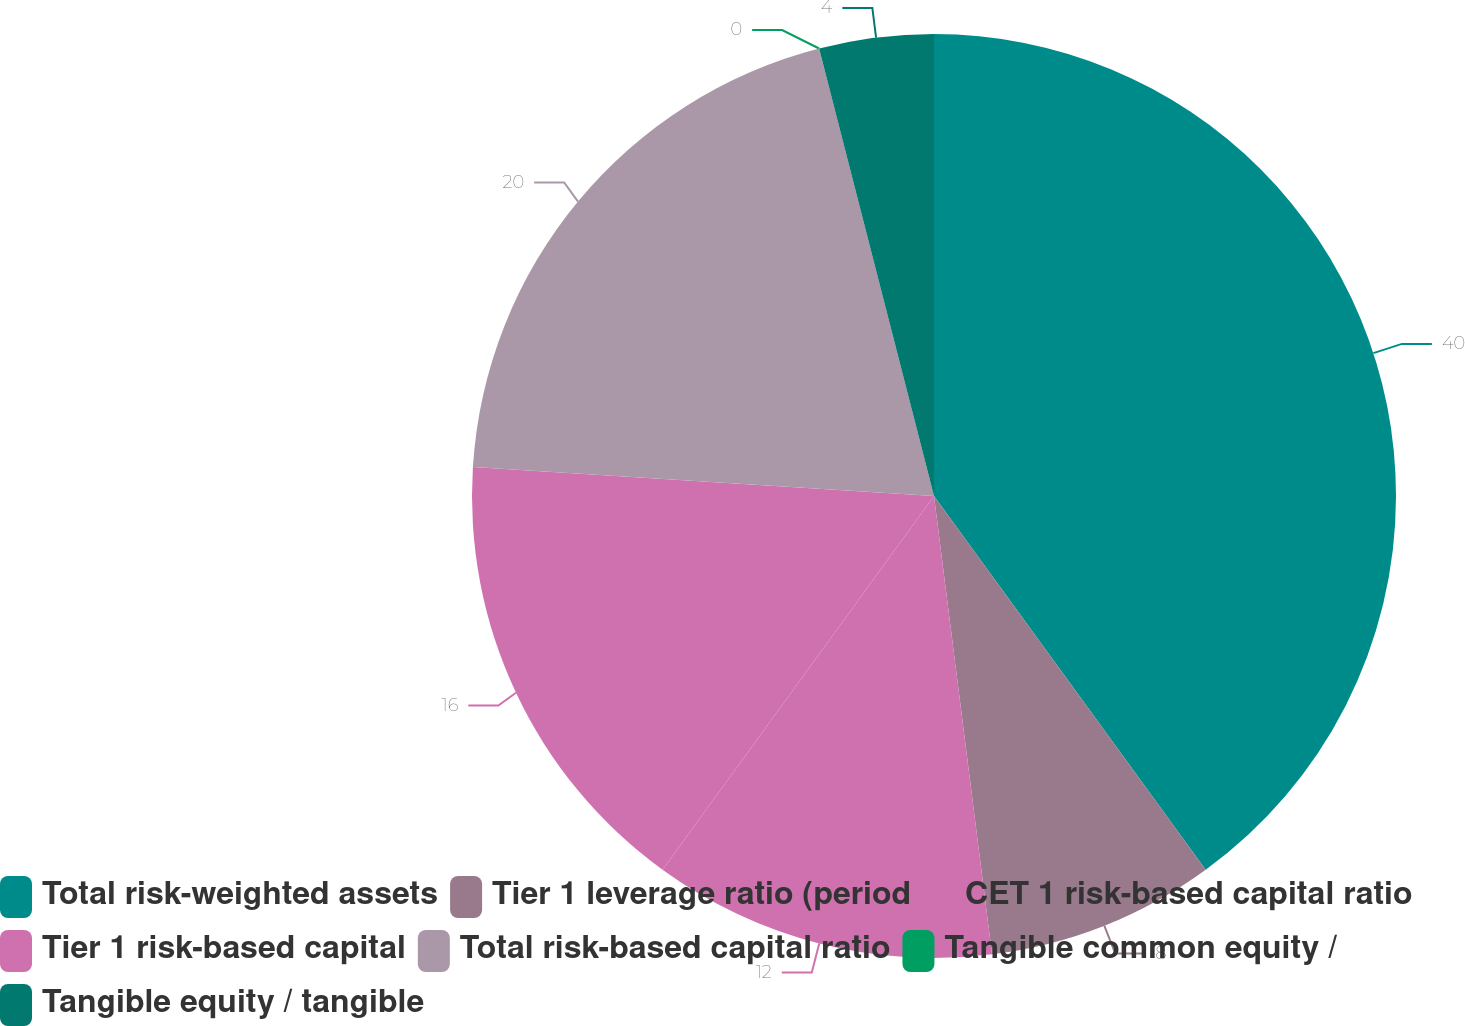<chart> <loc_0><loc_0><loc_500><loc_500><pie_chart><fcel>Total risk-weighted assets<fcel>Tier 1 leverage ratio (period<fcel>CET 1 risk-based capital ratio<fcel>Tier 1 risk-based capital<fcel>Total risk-based capital ratio<fcel>Tangible common equity /<fcel>Tangible equity / tangible<nl><fcel>39.99%<fcel>8.0%<fcel>12.0%<fcel>16.0%<fcel>20.0%<fcel>0.0%<fcel>4.0%<nl></chart> 